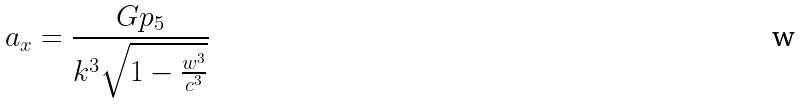Convert formula to latex. <formula><loc_0><loc_0><loc_500><loc_500>a _ { x } = \frac { G p _ { 5 } } { k ^ { 3 } \sqrt { 1 - \frac { w ^ { 3 } } { c ^ { 3 } } } }</formula> 